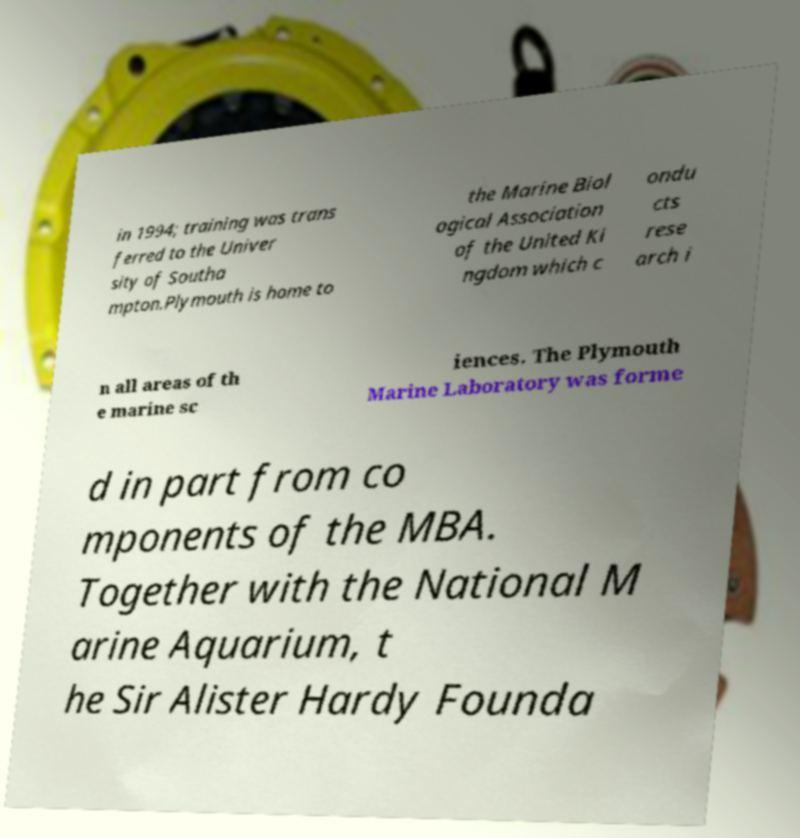Could you assist in decoding the text presented in this image and type it out clearly? in 1994; training was trans ferred to the Univer sity of Southa mpton.Plymouth is home to the Marine Biol ogical Association of the United Ki ngdom which c ondu cts rese arch i n all areas of th e marine sc iences. The Plymouth Marine Laboratory was forme d in part from co mponents of the MBA. Together with the National M arine Aquarium, t he Sir Alister Hardy Founda 